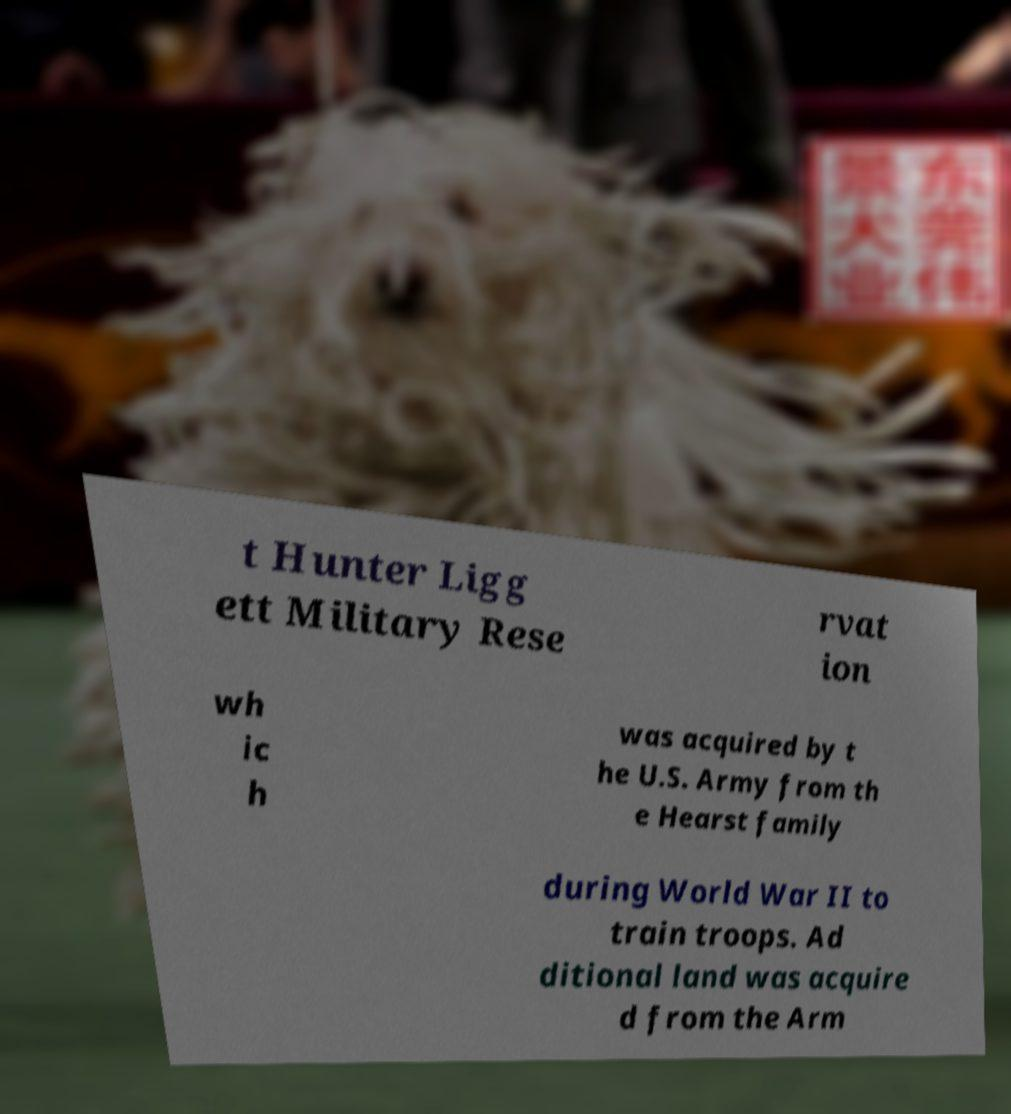Can you read and provide the text displayed in the image?This photo seems to have some interesting text. Can you extract and type it out for me? t Hunter Ligg ett Military Rese rvat ion wh ic h was acquired by t he U.S. Army from th e Hearst family during World War II to train troops. Ad ditional land was acquire d from the Arm 